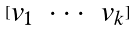Convert formula to latex. <formula><loc_0><loc_0><loc_500><loc_500>[ \begin{matrix} v _ { 1 } & \cdot \cdot \cdot & v _ { k } \end{matrix} ]</formula> 